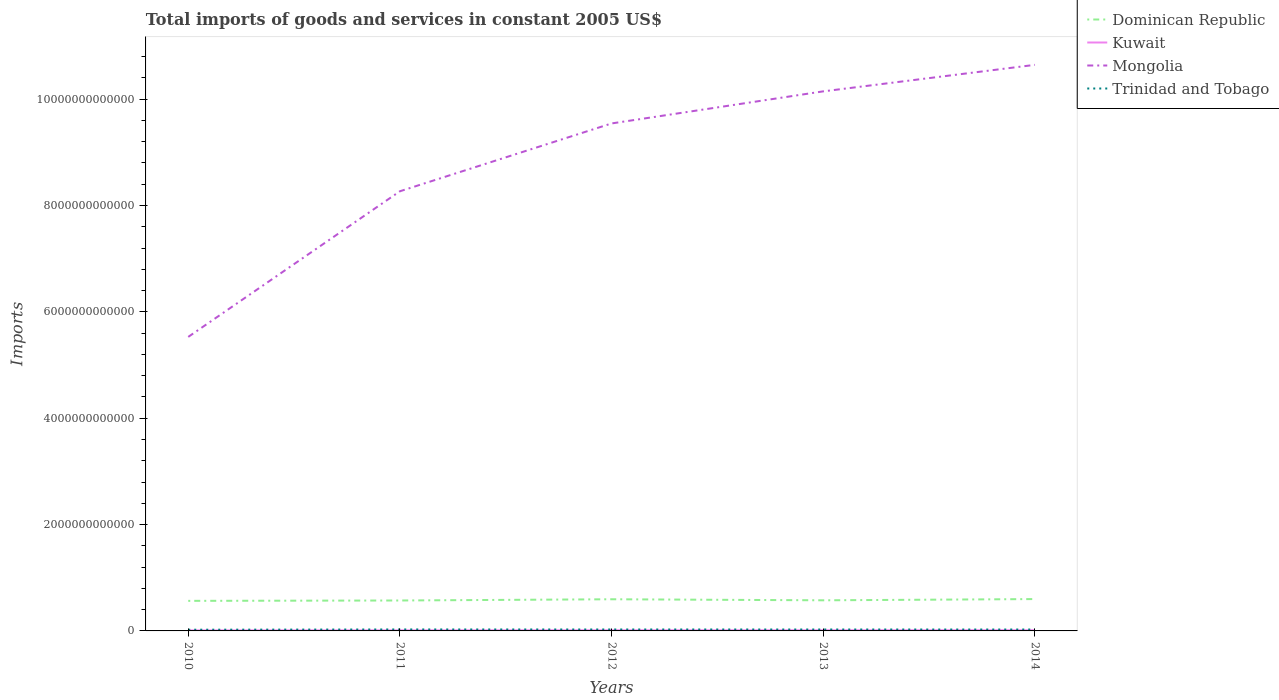Is the number of lines equal to the number of legend labels?
Give a very brief answer. Yes. Across all years, what is the maximum total imports of goods and services in Trinidad and Tobago?
Ensure brevity in your answer.  2.25e+1. In which year was the total imports of goods and services in Trinidad and Tobago maximum?
Provide a succinct answer. 2010. What is the total total imports of goods and services in Trinidad and Tobago in the graph?
Provide a short and direct response. -4.30e+09. What is the difference between the highest and the second highest total imports of goods and services in Dominican Republic?
Your answer should be very brief. 3.36e+1. What is the difference between the highest and the lowest total imports of goods and services in Mongolia?
Make the answer very short. 3. How many lines are there?
Offer a terse response. 4. What is the difference between two consecutive major ticks on the Y-axis?
Offer a very short reply. 2.00e+12. Are the values on the major ticks of Y-axis written in scientific E-notation?
Your answer should be compact. No. Does the graph contain any zero values?
Your answer should be compact. No. Does the graph contain grids?
Give a very brief answer. No. How are the legend labels stacked?
Ensure brevity in your answer.  Vertical. What is the title of the graph?
Your answer should be compact. Total imports of goods and services in constant 2005 US$. What is the label or title of the X-axis?
Offer a terse response. Years. What is the label or title of the Y-axis?
Make the answer very short. Imports. What is the Imports of Dominican Republic in 2010?
Your answer should be very brief. 5.65e+11. What is the Imports of Kuwait in 2010?
Offer a terse response. 1.00e+1. What is the Imports in Mongolia in 2010?
Your answer should be very brief. 5.53e+12. What is the Imports of Trinidad and Tobago in 2010?
Provide a short and direct response. 2.25e+1. What is the Imports in Dominican Republic in 2011?
Keep it short and to the point. 5.72e+11. What is the Imports of Kuwait in 2011?
Provide a short and direct response. 1.06e+1. What is the Imports of Mongolia in 2011?
Make the answer very short. 8.27e+12. What is the Imports in Trinidad and Tobago in 2011?
Give a very brief answer. 2.76e+1. What is the Imports of Dominican Republic in 2012?
Ensure brevity in your answer.  5.95e+11. What is the Imports of Kuwait in 2012?
Keep it short and to the point. 1.20e+1. What is the Imports in Mongolia in 2012?
Provide a short and direct response. 9.54e+12. What is the Imports of Trinidad and Tobago in 2012?
Provide a succinct answer. 2.70e+1. What is the Imports in Dominican Republic in 2013?
Provide a succinct answer. 5.76e+11. What is the Imports of Kuwait in 2013?
Keep it short and to the point. 1.20e+1. What is the Imports in Mongolia in 2013?
Your response must be concise. 1.01e+13. What is the Imports in Trinidad and Tobago in 2013?
Provide a succinct answer. 2.68e+1. What is the Imports of Dominican Republic in 2014?
Provide a succinct answer. 5.99e+11. What is the Imports of Kuwait in 2014?
Offer a terse response. 1.30e+1. What is the Imports in Mongolia in 2014?
Provide a short and direct response. 1.06e+13. What is the Imports of Trinidad and Tobago in 2014?
Offer a very short reply. 2.63e+1. Across all years, what is the maximum Imports in Dominican Republic?
Ensure brevity in your answer.  5.99e+11. Across all years, what is the maximum Imports of Kuwait?
Offer a very short reply. 1.30e+1. Across all years, what is the maximum Imports of Mongolia?
Your answer should be compact. 1.06e+13. Across all years, what is the maximum Imports of Trinidad and Tobago?
Offer a terse response. 2.76e+1. Across all years, what is the minimum Imports in Dominican Republic?
Offer a very short reply. 5.65e+11. Across all years, what is the minimum Imports of Kuwait?
Make the answer very short. 1.00e+1. Across all years, what is the minimum Imports of Mongolia?
Your answer should be compact. 5.53e+12. Across all years, what is the minimum Imports in Trinidad and Tobago?
Your answer should be compact. 2.25e+1. What is the total Imports in Dominican Republic in the graph?
Your response must be concise. 2.91e+12. What is the total Imports of Kuwait in the graph?
Offer a very short reply. 5.76e+1. What is the total Imports of Mongolia in the graph?
Your answer should be very brief. 4.41e+13. What is the total Imports in Trinidad and Tobago in the graph?
Your response must be concise. 1.30e+11. What is the difference between the Imports of Dominican Republic in 2010 and that in 2011?
Provide a short and direct response. -6.81e+09. What is the difference between the Imports in Kuwait in 2010 and that in 2011?
Offer a terse response. -5.19e+08. What is the difference between the Imports of Mongolia in 2010 and that in 2011?
Ensure brevity in your answer.  -2.74e+12. What is the difference between the Imports of Trinidad and Tobago in 2010 and that in 2011?
Make the answer very short. -5.08e+09. What is the difference between the Imports in Dominican Republic in 2010 and that in 2012?
Your response must be concise. -3.00e+1. What is the difference between the Imports in Kuwait in 2010 and that in 2012?
Make the answer very short. -1.99e+09. What is the difference between the Imports of Mongolia in 2010 and that in 2012?
Provide a short and direct response. -4.01e+12. What is the difference between the Imports of Trinidad and Tobago in 2010 and that in 2012?
Your response must be concise. -4.47e+09. What is the difference between the Imports of Dominican Republic in 2010 and that in 2013?
Give a very brief answer. -1.02e+1. What is the difference between the Imports of Kuwait in 2010 and that in 2013?
Make the answer very short. -1.98e+09. What is the difference between the Imports in Mongolia in 2010 and that in 2013?
Ensure brevity in your answer.  -4.62e+12. What is the difference between the Imports of Trinidad and Tobago in 2010 and that in 2013?
Give a very brief answer. -4.30e+09. What is the difference between the Imports of Dominican Republic in 2010 and that in 2014?
Your answer should be compact. -3.36e+1. What is the difference between the Imports of Kuwait in 2010 and that in 2014?
Your response must be concise. -2.91e+09. What is the difference between the Imports in Mongolia in 2010 and that in 2014?
Your answer should be very brief. -5.12e+12. What is the difference between the Imports of Trinidad and Tobago in 2010 and that in 2014?
Give a very brief answer. -3.78e+09. What is the difference between the Imports in Dominican Republic in 2011 and that in 2012?
Provide a succinct answer. -2.32e+1. What is the difference between the Imports of Kuwait in 2011 and that in 2012?
Offer a very short reply. -1.47e+09. What is the difference between the Imports of Mongolia in 2011 and that in 2012?
Offer a very short reply. -1.28e+12. What is the difference between the Imports of Trinidad and Tobago in 2011 and that in 2012?
Provide a succinct answer. 6.05e+08. What is the difference between the Imports in Dominican Republic in 2011 and that in 2013?
Provide a short and direct response. -3.41e+09. What is the difference between the Imports of Kuwait in 2011 and that in 2013?
Offer a very short reply. -1.46e+09. What is the difference between the Imports in Mongolia in 2011 and that in 2013?
Give a very brief answer. -1.88e+12. What is the difference between the Imports of Trinidad and Tobago in 2011 and that in 2013?
Make the answer very short. 7.79e+08. What is the difference between the Imports in Dominican Republic in 2011 and that in 2014?
Your answer should be compact. -2.68e+1. What is the difference between the Imports of Kuwait in 2011 and that in 2014?
Provide a succinct answer. -2.39e+09. What is the difference between the Imports of Mongolia in 2011 and that in 2014?
Make the answer very short. -2.38e+12. What is the difference between the Imports of Trinidad and Tobago in 2011 and that in 2014?
Keep it short and to the point. 1.30e+09. What is the difference between the Imports in Dominican Republic in 2012 and that in 2013?
Provide a succinct answer. 1.98e+1. What is the difference between the Imports of Kuwait in 2012 and that in 2013?
Keep it short and to the point. 1.02e+07. What is the difference between the Imports of Mongolia in 2012 and that in 2013?
Your response must be concise. -6.03e+11. What is the difference between the Imports in Trinidad and Tobago in 2012 and that in 2013?
Your answer should be very brief. 1.74e+08. What is the difference between the Imports in Dominican Republic in 2012 and that in 2014?
Your response must be concise. -3.56e+09. What is the difference between the Imports of Kuwait in 2012 and that in 2014?
Provide a succinct answer. -9.17e+08. What is the difference between the Imports of Mongolia in 2012 and that in 2014?
Provide a short and direct response. -1.10e+12. What is the difference between the Imports in Trinidad and Tobago in 2012 and that in 2014?
Your answer should be very brief. 6.90e+08. What is the difference between the Imports in Dominican Republic in 2013 and that in 2014?
Provide a succinct answer. -2.34e+1. What is the difference between the Imports in Kuwait in 2013 and that in 2014?
Make the answer very short. -9.27e+08. What is the difference between the Imports of Mongolia in 2013 and that in 2014?
Offer a terse response. -4.98e+11. What is the difference between the Imports in Trinidad and Tobago in 2013 and that in 2014?
Give a very brief answer. 5.16e+08. What is the difference between the Imports in Dominican Republic in 2010 and the Imports in Kuwait in 2011?
Offer a very short reply. 5.55e+11. What is the difference between the Imports of Dominican Republic in 2010 and the Imports of Mongolia in 2011?
Provide a short and direct response. -7.70e+12. What is the difference between the Imports in Dominican Republic in 2010 and the Imports in Trinidad and Tobago in 2011?
Your answer should be very brief. 5.38e+11. What is the difference between the Imports in Kuwait in 2010 and the Imports in Mongolia in 2011?
Give a very brief answer. -8.26e+12. What is the difference between the Imports of Kuwait in 2010 and the Imports of Trinidad and Tobago in 2011?
Ensure brevity in your answer.  -1.76e+1. What is the difference between the Imports in Mongolia in 2010 and the Imports in Trinidad and Tobago in 2011?
Provide a succinct answer. 5.50e+12. What is the difference between the Imports in Dominican Republic in 2010 and the Imports in Kuwait in 2012?
Make the answer very short. 5.53e+11. What is the difference between the Imports in Dominican Republic in 2010 and the Imports in Mongolia in 2012?
Make the answer very short. -8.98e+12. What is the difference between the Imports of Dominican Republic in 2010 and the Imports of Trinidad and Tobago in 2012?
Provide a short and direct response. 5.38e+11. What is the difference between the Imports in Kuwait in 2010 and the Imports in Mongolia in 2012?
Provide a succinct answer. -9.53e+12. What is the difference between the Imports in Kuwait in 2010 and the Imports in Trinidad and Tobago in 2012?
Your response must be concise. -1.70e+1. What is the difference between the Imports of Mongolia in 2010 and the Imports of Trinidad and Tobago in 2012?
Make the answer very short. 5.50e+12. What is the difference between the Imports in Dominican Republic in 2010 and the Imports in Kuwait in 2013?
Provide a succinct answer. 5.53e+11. What is the difference between the Imports of Dominican Republic in 2010 and the Imports of Mongolia in 2013?
Provide a short and direct response. -9.58e+12. What is the difference between the Imports in Dominican Republic in 2010 and the Imports in Trinidad and Tobago in 2013?
Ensure brevity in your answer.  5.39e+11. What is the difference between the Imports in Kuwait in 2010 and the Imports in Mongolia in 2013?
Ensure brevity in your answer.  -1.01e+13. What is the difference between the Imports in Kuwait in 2010 and the Imports in Trinidad and Tobago in 2013?
Provide a succinct answer. -1.68e+1. What is the difference between the Imports of Mongolia in 2010 and the Imports of Trinidad and Tobago in 2013?
Give a very brief answer. 5.50e+12. What is the difference between the Imports in Dominican Republic in 2010 and the Imports in Kuwait in 2014?
Make the answer very short. 5.52e+11. What is the difference between the Imports of Dominican Republic in 2010 and the Imports of Mongolia in 2014?
Your response must be concise. -1.01e+13. What is the difference between the Imports of Dominican Republic in 2010 and the Imports of Trinidad and Tobago in 2014?
Offer a terse response. 5.39e+11. What is the difference between the Imports of Kuwait in 2010 and the Imports of Mongolia in 2014?
Keep it short and to the point. -1.06e+13. What is the difference between the Imports in Kuwait in 2010 and the Imports in Trinidad and Tobago in 2014?
Provide a succinct answer. -1.63e+1. What is the difference between the Imports in Mongolia in 2010 and the Imports in Trinidad and Tobago in 2014?
Offer a terse response. 5.50e+12. What is the difference between the Imports of Dominican Republic in 2011 and the Imports of Kuwait in 2012?
Provide a succinct answer. 5.60e+11. What is the difference between the Imports of Dominican Republic in 2011 and the Imports of Mongolia in 2012?
Provide a succinct answer. -8.97e+12. What is the difference between the Imports in Dominican Republic in 2011 and the Imports in Trinidad and Tobago in 2012?
Offer a very short reply. 5.45e+11. What is the difference between the Imports in Kuwait in 2011 and the Imports in Mongolia in 2012?
Give a very brief answer. -9.53e+12. What is the difference between the Imports of Kuwait in 2011 and the Imports of Trinidad and Tobago in 2012?
Your answer should be compact. -1.64e+1. What is the difference between the Imports of Mongolia in 2011 and the Imports of Trinidad and Tobago in 2012?
Make the answer very short. 8.24e+12. What is the difference between the Imports in Dominican Republic in 2011 and the Imports in Kuwait in 2013?
Offer a terse response. 5.60e+11. What is the difference between the Imports in Dominican Republic in 2011 and the Imports in Mongolia in 2013?
Provide a short and direct response. -9.57e+12. What is the difference between the Imports of Dominican Republic in 2011 and the Imports of Trinidad and Tobago in 2013?
Give a very brief answer. 5.45e+11. What is the difference between the Imports of Kuwait in 2011 and the Imports of Mongolia in 2013?
Ensure brevity in your answer.  -1.01e+13. What is the difference between the Imports of Kuwait in 2011 and the Imports of Trinidad and Tobago in 2013?
Offer a very short reply. -1.63e+1. What is the difference between the Imports of Mongolia in 2011 and the Imports of Trinidad and Tobago in 2013?
Keep it short and to the point. 8.24e+12. What is the difference between the Imports in Dominican Republic in 2011 and the Imports in Kuwait in 2014?
Your answer should be compact. 5.59e+11. What is the difference between the Imports of Dominican Republic in 2011 and the Imports of Mongolia in 2014?
Offer a very short reply. -1.01e+13. What is the difference between the Imports in Dominican Republic in 2011 and the Imports in Trinidad and Tobago in 2014?
Give a very brief answer. 5.46e+11. What is the difference between the Imports in Kuwait in 2011 and the Imports in Mongolia in 2014?
Keep it short and to the point. -1.06e+13. What is the difference between the Imports in Kuwait in 2011 and the Imports in Trinidad and Tobago in 2014?
Provide a succinct answer. -1.57e+1. What is the difference between the Imports in Mongolia in 2011 and the Imports in Trinidad and Tobago in 2014?
Provide a succinct answer. 8.24e+12. What is the difference between the Imports of Dominican Republic in 2012 and the Imports of Kuwait in 2013?
Your answer should be compact. 5.83e+11. What is the difference between the Imports in Dominican Republic in 2012 and the Imports in Mongolia in 2013?
Ensure brevity in your answer.  -9.55e+12. What is the difference between the Imports of Dominican Republic in 2012 and the Imports of Trinidad and Tobago in 2013?
Provide a short and direct response. 5.69e+11. What is the difference between the Imports in Kuwait in 2012 and the Imports in Mongolia in 2013?
Ensure brevity in your answer.  -1.01e+13. What is the difference between the Imports of Kuwait in 2012 and the Imports of Trinidad and Tobago in 2013?
Make the answer very short. -1.48e+1. What is the difference between the Imports in Mongolia in 2012 and the Imports in Trinidad and Tobago in 2013?
Your answer should be very brief. 9.52e+12. What is the difference between the Imports of Dominican Republic in 2012 and the Imports of Kuwait in 2014?
Offer a terse response. 5.82e+11. What is the difference between the Imports in Dominican Republic in 2012 and the Imports in Mongolia in 2014?
Keep it short and to the point. -1.00e+13. What is the difference between the Imports in Dominican Republic in 2012 and the Imports in Trinidad and Tobago in 2014?
Offer a very short reply. 5.69e+11. What is the difference between the Imports of Kuwait in 2012 and the Imports of Mongolia in 2014?
Provide a short and direct response. -1.06e+13. What is the difference between the Imports of Kuwait in 2012 and the Imports of Trinidad and Tobago in 2014?
Make the answer very short. -1.43e+1. What is the difference between the Imports in Mongolia in 2012 and the Imports in Trinidad and Tobago in 2014?
Provide a short and direct response. 9.52e+12. What is the difference between the Imports of Dominican Republic in 2013 and the Imports of Kuwait in 2014?
Make the answer very short. 5.63e+11. What is the difference between the Imports in Dominican Republic in 2013 and the Imports in Mongolia in 2014?
Offer a terse response. -1.01e+13. What is the difference between the Imports in Dominican Republic in 2013 and the Imports in Trinidad and Tobago in 2014?
Provide a short and direct response. 5.49e+11. What is the difference between the Imports of Kuwait in 2013 and the Imports of Mongolia in 2014?
Offer a terse response. -1.06e+13. What is the difference between the Imports of Kuwait in 2013 and the Imports of Trinidad and Tobago in 2014?
Provide a short and direct response. -1.43e+1. What is the difference between the Imports of Mongolia in 2013 and the Imports of Trinidad and Tobago in 2014?
Provide a succinct answer. 1.01e+13. What is the average Imports in Dominican Republic per year?
Make the answer very short. 5.82e+11. What is the average Imports of Kuwait per year?
Offer a very short reply. 1.15e+1. What is the average Imports of Mongolia per year?
Make the answer very short. 8.83e+12. What is the average Imports in Trinidad and Tobago per year?
Ensure brevity in your answer.  2.60e+1. In the year 2010, what is the difference between the Imports of Dominican Republic and Imports of Kuwait?
Your answer should be very brief. 5.55e+11. In the year 2010, what is the difference between the Imports in Dominican Republic and Imports in Mongolia?
Provide a succinct answer. -4.96e+12. In the year 2010, what is the difference between the Imports in Dominican Republic and Imports in Trinidad and Tobago?
Your response must be concise. 5.43e+11. In the year 2010, what is the difference between the Imports in Kuwait and Imports in Mongolia?
Give a very brief answer. -5.52e+12. In the year 2010, what is the difference between the Imports of Kuwait and Imports of Trinidad and Tobago?
Offer a very short reply. -1.25e+1. In the year 2010, what is the difference between the Imports in Mongolia and Imports in Trinidad and Tobago?
Provide a short and direct response. 5.51e+12. In the year 2011, what is the difference between the Imports in Dominican Republic and Imports in Kuwait?
Offer a terse response. 5.62e+11. In the year 2011, what is the difference between the Imports of Dominican Republic and Imports of Mongolia?
Offer a very short reply. -7.70e+12. In the year 2011, what is the difference between the Imports of Dominican Republic and Imports of Trinidad and Tobago?
Give a very brief answer. 5.45e+11. In the year 2011, what is the difference between the Imports of Kuwait and Imports of Mongolia?
Provide a short and direct response. -8.26e+12. In the year 2011, what is the difference between the Imports in Kuwait and Imports in Trinidad and Tobago?
Give a very brief answer. -1.70e+1. In the year 2011, what is the difference between the Imports in Mongolia and Imports in Trinidad and Tobago?
Give a very brief answer. 8.24e+12. In the year 2012, what is the difference between the Imports in Dominican Republic and Imports in Kuwait?
Offer a terse response. 5.83e+11. In the year 2012, what is the difference between the Imports in Dominican Republic and Imports in Mongolia?
Your response must be concise. -8.95e+12. In the year 2012, what is the difference between the Imports of Dominican Republic and Imports of Trinidad and Tobago?
Make the answer very short. 5.68e+11. In the year 2012, what is the difference between the Imports in Kuwait and Imports in Mongolia?
Keep it short and to the point. -9.53e+12. In the year 2012, what is the difference between the Imports in Kuwait and Imports in Trinidad and Tobago?
Your answer should be very brief. -1.50e+1. In the year 2012, what is the difference between the Imports in Mongolia and Imports in Trinidad and Tobago?
Provide a short and direct response. 9.52e+12. In the year 2013, what is the difference between the Imports of Dominican Republic and Imports of Kuwait?
Offer a terse response. 5.64e+11. In the year 2013, what is the difference between the Imports in Dominican Republic and Imports in Mongolia?
Provide a short and direct response. -9.57e+12. In the year 2013, what is the difference between the Imports of Dominican Republic and Imports of Trinidad and Tobago?
Keep it short and to the point. 5.49e+11. In the year 2013, what is the difference between the Imports in Kuwait and Imports in Mongolia?
Give a very brief answer. -1.01e+13. In the year 2013, what is the difference between the Imports in Kuwait and Imports in Trinidad and Tobago?
Your answer should be very brief. -1.48e+1. In the year 2013, what is the difference between the Imports in Mongolia and Imports in Trinidad and Tobago?
Offer a very short reply. 1.01e+13. In the year 2014, what is the difference between the Imports of Dominican Republic and Imports of Kuwait?
Keep it short and to the point. 5.86e+11. In the year 2014, what is the difference between the Imports in Dominican Republic and Imports in Mongolia?
Provide a succinct answer. -1.00e+13. In the year 2014, what is the difference between the Imports of Dominican Republic and Imports of Trinidad and Tobago?
Ensure brevity in your answer.  5.73e+11. In the year 2014, what is the difference between the Imports of Kuwait and Imports of Mongolia?
Keep it short and to the point. -1.06e+13. In the year 2014, what is the difference between the Imports in Kuwait and Imports in Trinidad and Tobago?
Your response must be concise. -1.34e+1. In the year 2014, what is the difference between the Imports in Mongolia and Imports in Trinidad and Tobago?
Your answer should be compact. 1.06e+13. What is the ratio of the Imports in Kuwait in 2010 to that in 2011?
Your response must be concise. 0.95. What is the ratio of the Imports of Mongolia in 2010 to that in 2011?
Provide a succinct answer. 0.67. What is the ratio of the Imports of Trinidad and Tobago in 2010 to that in 2011?
Your answer should be very brief. 0.82. What is the ratio of the Imports of Dominican Republic in 2010 to that in 2012?
Offer a very short reply. 0.95. What is the ratio of the Imports in Kuwait in 2010 to that in 2012?
Ensure brevity in your answer.  0.83. What is the ratio of the Imports in Mongolia in 2010 to that in 2012?
Offer a terse response. 0.58. What is the ratio of the Imports of Trinidad and Tobago in 2010 to that in 2012?
Your answer should be very brief. 0.83. What is the ratio of the Imports in Dominican Republic in 2010 to that in 2013?
Give a very brief answer. 0.98. What is the ratio of the Imports in Kuwait in 2010 to that in 2013?
Your response must be concise. 0.84. What is the ratio of the Imports of Mongolia in 2010 to that in 2013?
Your response must be concise. 0.54. What is the ratio of the Imports in Trinidad and Tobago in 2010 to that in 2013?
Provide a short and direct response. 0.84. What is the ratio of the Imports in Dominican Republic in 2010 to that in 2014?
Ensure brevity in your answer.  0.94. What is the ratio of the Imports in Kuwait in 2010 to that in 2014?
Your response must be concise. 0.78. What is the ratio of the Imports in Mongolia in 2010 to that in 2014?
Provide a short and direct response. 0.52. What is the ratio of the Imports in Trinidad and Tobago in 2010 to that in 2014?
Give a very brief answer. 0.86. What is the ratio of the Imports of Dominican Republic in 2011 to that in 2012?
Offer a very short reply. 0.96. What is the ratio of the Imports of Kuwait in 2011 to that in 2012?
Your answer should be compact. 0.88. What is the ratio of the Imports in Mongolia in 2011 to that in 2012?
Provide a succinct answer. 0.87. What is the ratio of the Imports of Trinidad and Tobago in 2011 to that in 2012?
Offer a very short reply. 1.02. What is the ratio of the Imports of Kuwait in 2011 to that in 2013?
Offer a terse response. 0.88. What is the ratio of the Imports in Mongolia in 2011 to that in 2013?
Keep it short and to the point. 0.81. What is the ratio of the Imports of Trinidad and Tobago in 2011 to that in 2013?
Give a very brief answer. 1.03. What is the ratio of the Imports of Dominican Republic in 2011 to that in 2014?
Offer a very short reply. 0.96. What is the ratio of the Imports of Kuwait in 2011 to that in 2014?
Offer a very short reply. 0.82. What is the ratio of the Imports of Mongolia in 2011 to that in 2014?
Offer a very short reply. 0.78. What is the ratio of the Imports in Trinidad and Tobago in 2011 to that in 2014?
Your answer should be compact. 1.05. What is the ratio of the Imports of Dominican Republic in 2012 to that in 2013?
Offer a terse response. 1.03. What is the ratio of the Imports in Kuwait in 2012 to that in 2013?
Your answer should be compact. 1. What is the ratio of the Imports of Mongolia in 2012 to that in 2013?
Provide a succinct answer. 0.94. What is the ratio of the Imports of Kuwait in 2012 to that in 2014?
Keep it short and to the point. 0.93. What is the ratio of the Imports in Mongolia in 2012 to that in 2014?
Ensure brevity in your answer.  0.9. What is the ratio of the Imports of Trinidad and Tobago in 2012 to that in 2014?
Provide a succinct answer. 1.03. What is the ratio of the Imports in Kuwait in 2013 to that in 2014?
Your answer should be very brief. 0.93. What is the ratio of the Imports of Mongolia in 2013 to that in 2014?
Provide a short and direct response. 0.95. What is the ratio of the Imports in Trinidad and Tobago in 2013 to that in 2014?
Ensure brevity in your answer.  1.02. What is the difference between the highest and the second highest Imports of Dominican Republic?
Provide a short and direct response. 3.56e+09. What is the difference between the highest and the second highest Imports of Kuwait?
Offer a very short reply. 9.17e+08. What is the difference between the highest and the second highest Imports in Mongolia?
Provide a succinct answer. 4.98e+11. What is the difference between the highest and the second highest Imports in Trinidad and Tobago?
Your answer should be very brief. 6.05e+08. What is the difference between the highest and the lowest Imports in Dominican Republic?
Give a very brief answer. 3.36e+1. What is the difference between the highest and the lowest Imports of Kuwait?
Provide a short and direct response. 2.91e+09. What is the difference between the highest and the lowest Imports of Mongolia?
Your answer should be compact. 5.12e+12. What is the difference between the highest and the lowest Imports of Trinidad and Tobago?
Make the answer very short. 5.08e+09. 